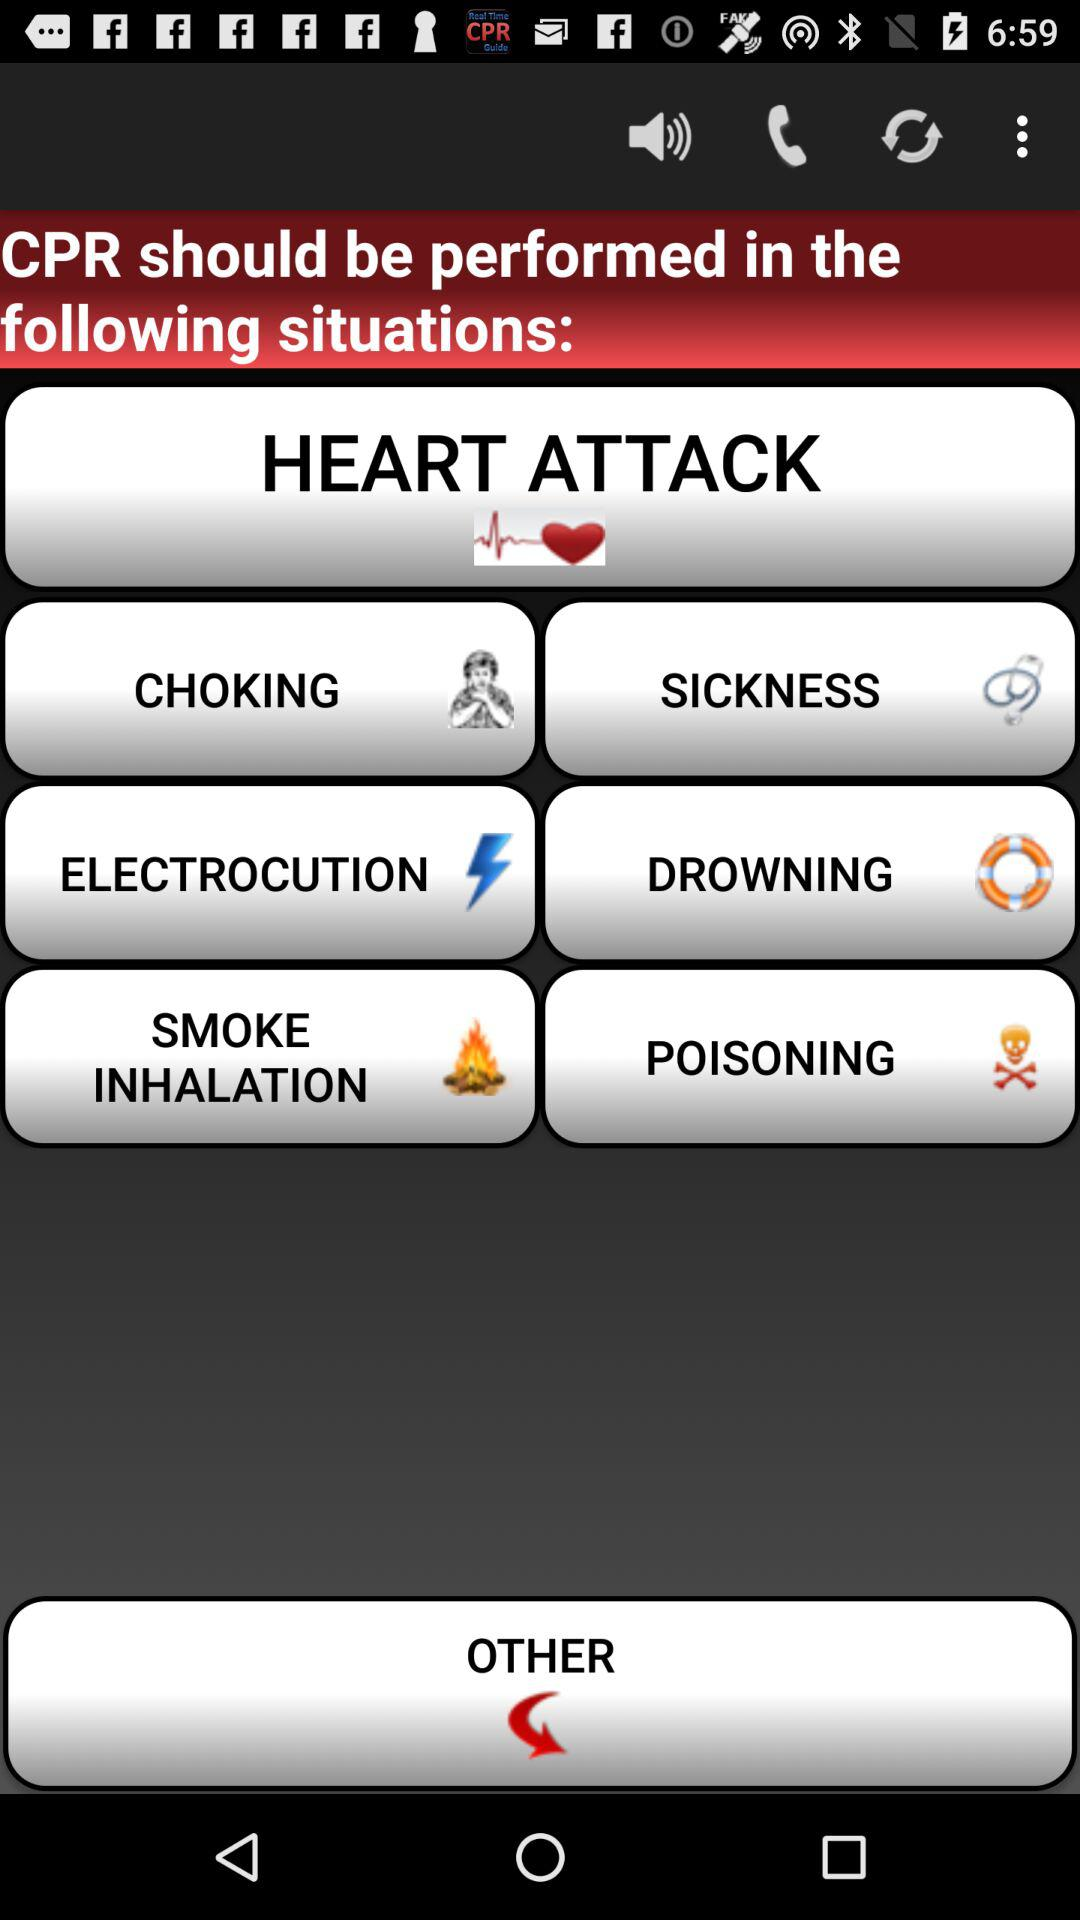In which situation should CPR be performed? CPR should be performed in the following situations: "HEART ATTACK", "CHOKING", "SICKNESS", "ELECTROCUTION", "DROWNING", "SMOKE INHALATION" and "POISONING". 